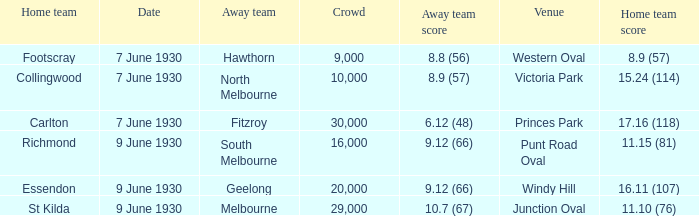Which opposing team played against footscray? Hawthorn. 